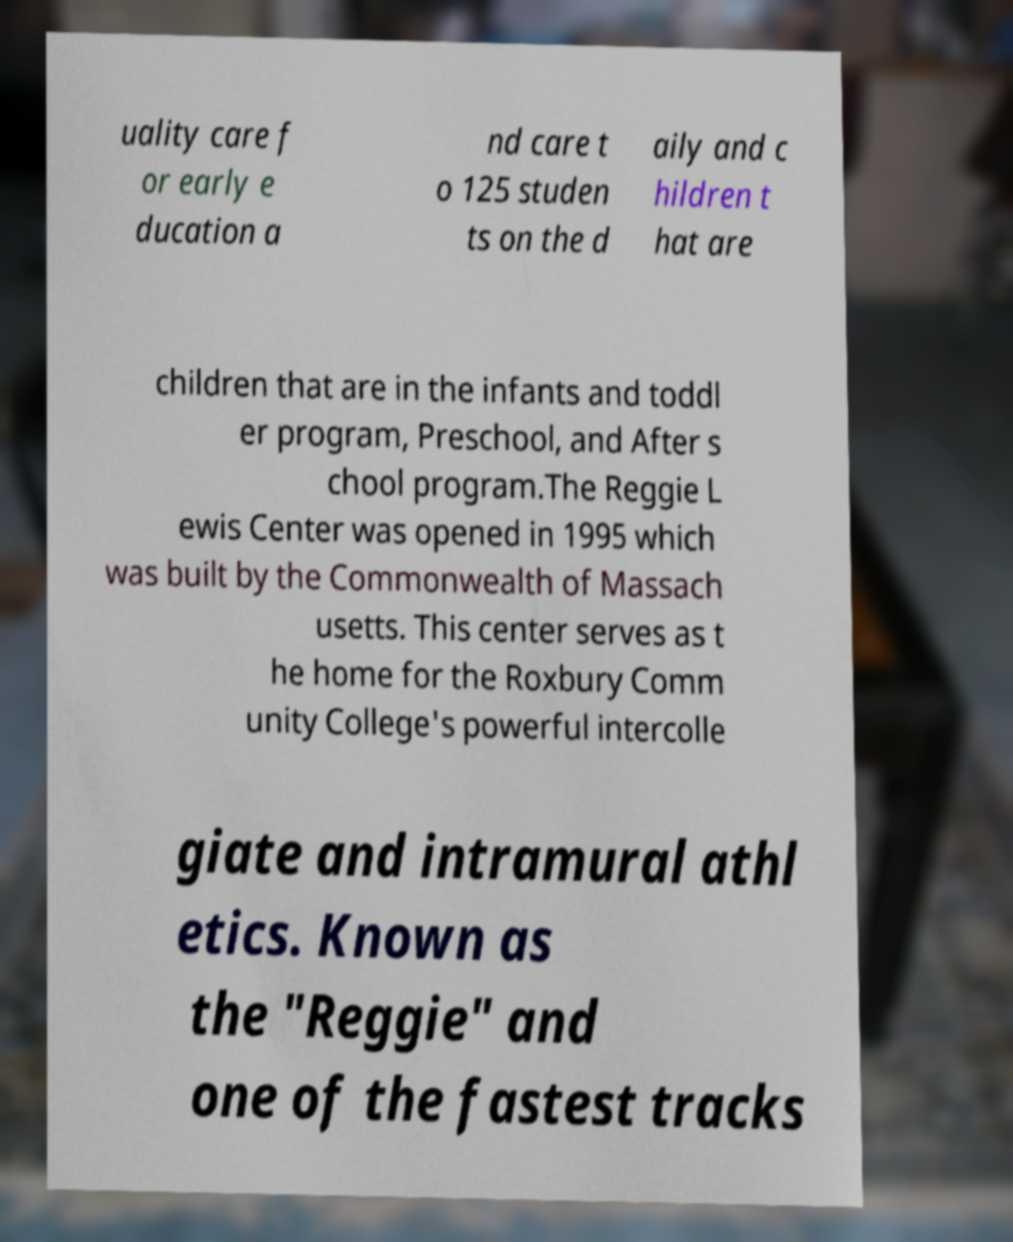Please identify and transcribe the text found in this image. uality care f or early e ducation a nd care t o 125 studen ts on the d aily and c hildren t hat are children that are in the infants and toddl er program, Preschool, and After s chool program.The Reggie L ewis Center was opened in 1995 which was built by the Commonwealth of Massach usetts. This center serves as t he home for the Roxbury Comm unity College's powerful intercolle giate and intramural athl etics. Known as the "Reggie" and one of the fastest tracks 